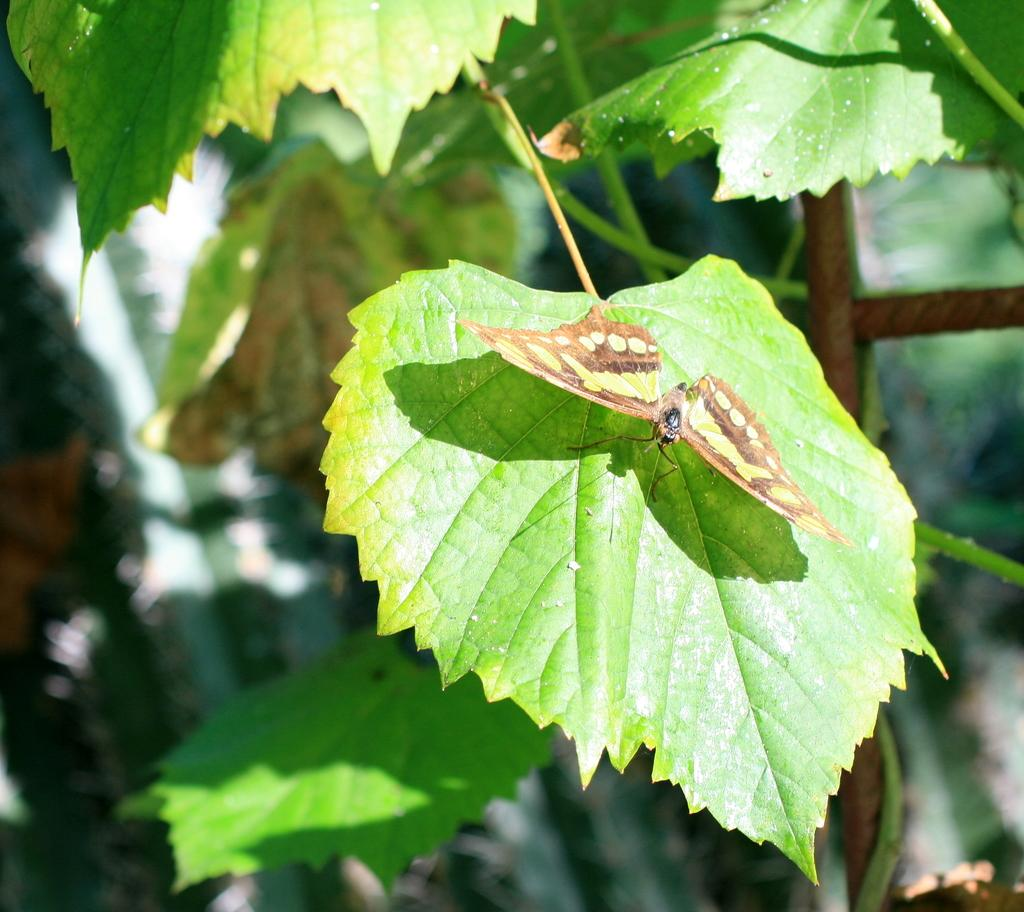What is the main subject of the image? There is a butterfly on a green leaf in the image. What type of plant is the butterfly sitting on? The butterfly is on a green leaf. What can be seen at the top of the image? Leaves and stems are visible at the top of the image. What is the appearance of the background in the image? The background of the image has a blurred view. What else can be seen in the background of the image? Leaves are present in the background of the image, along with some unspecified objects. What time of day is it in the image, and what is the mom doing? The time of day is not specified in the image, and there is no mention of a mom or any activity she might be doing. 